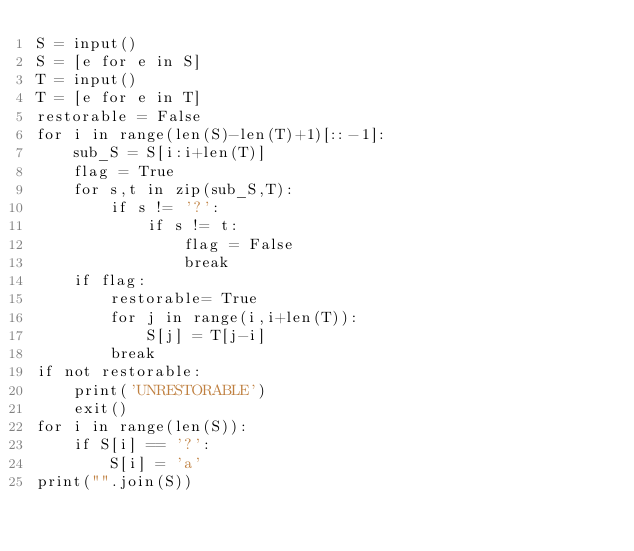<code> <loc_0><loc_0><loc_500><loc_500><_Python_>S = input()
S = [e for e in S]
T = input()
T = [e for e in T]
restorable = False
for i in range(len(S)-len(T)+1)[::-1]:
    sub_S = S[i:i+len(T)]
    flag = True
    for s,t in zip(sub_S,T):
        if s != '?':
            if s != t:
                flag = False
                break
    if flag:
        restorable= True
        for j in range(i,i+len(T)):
            S[j] = T[j-i]
        break
if not restorable:
    print('UNRESTORABLE')
    exit()
for i in range(len(S)):
    if S[i] == '?':
        S[i] = 'a'
print("".join(S))</code> 